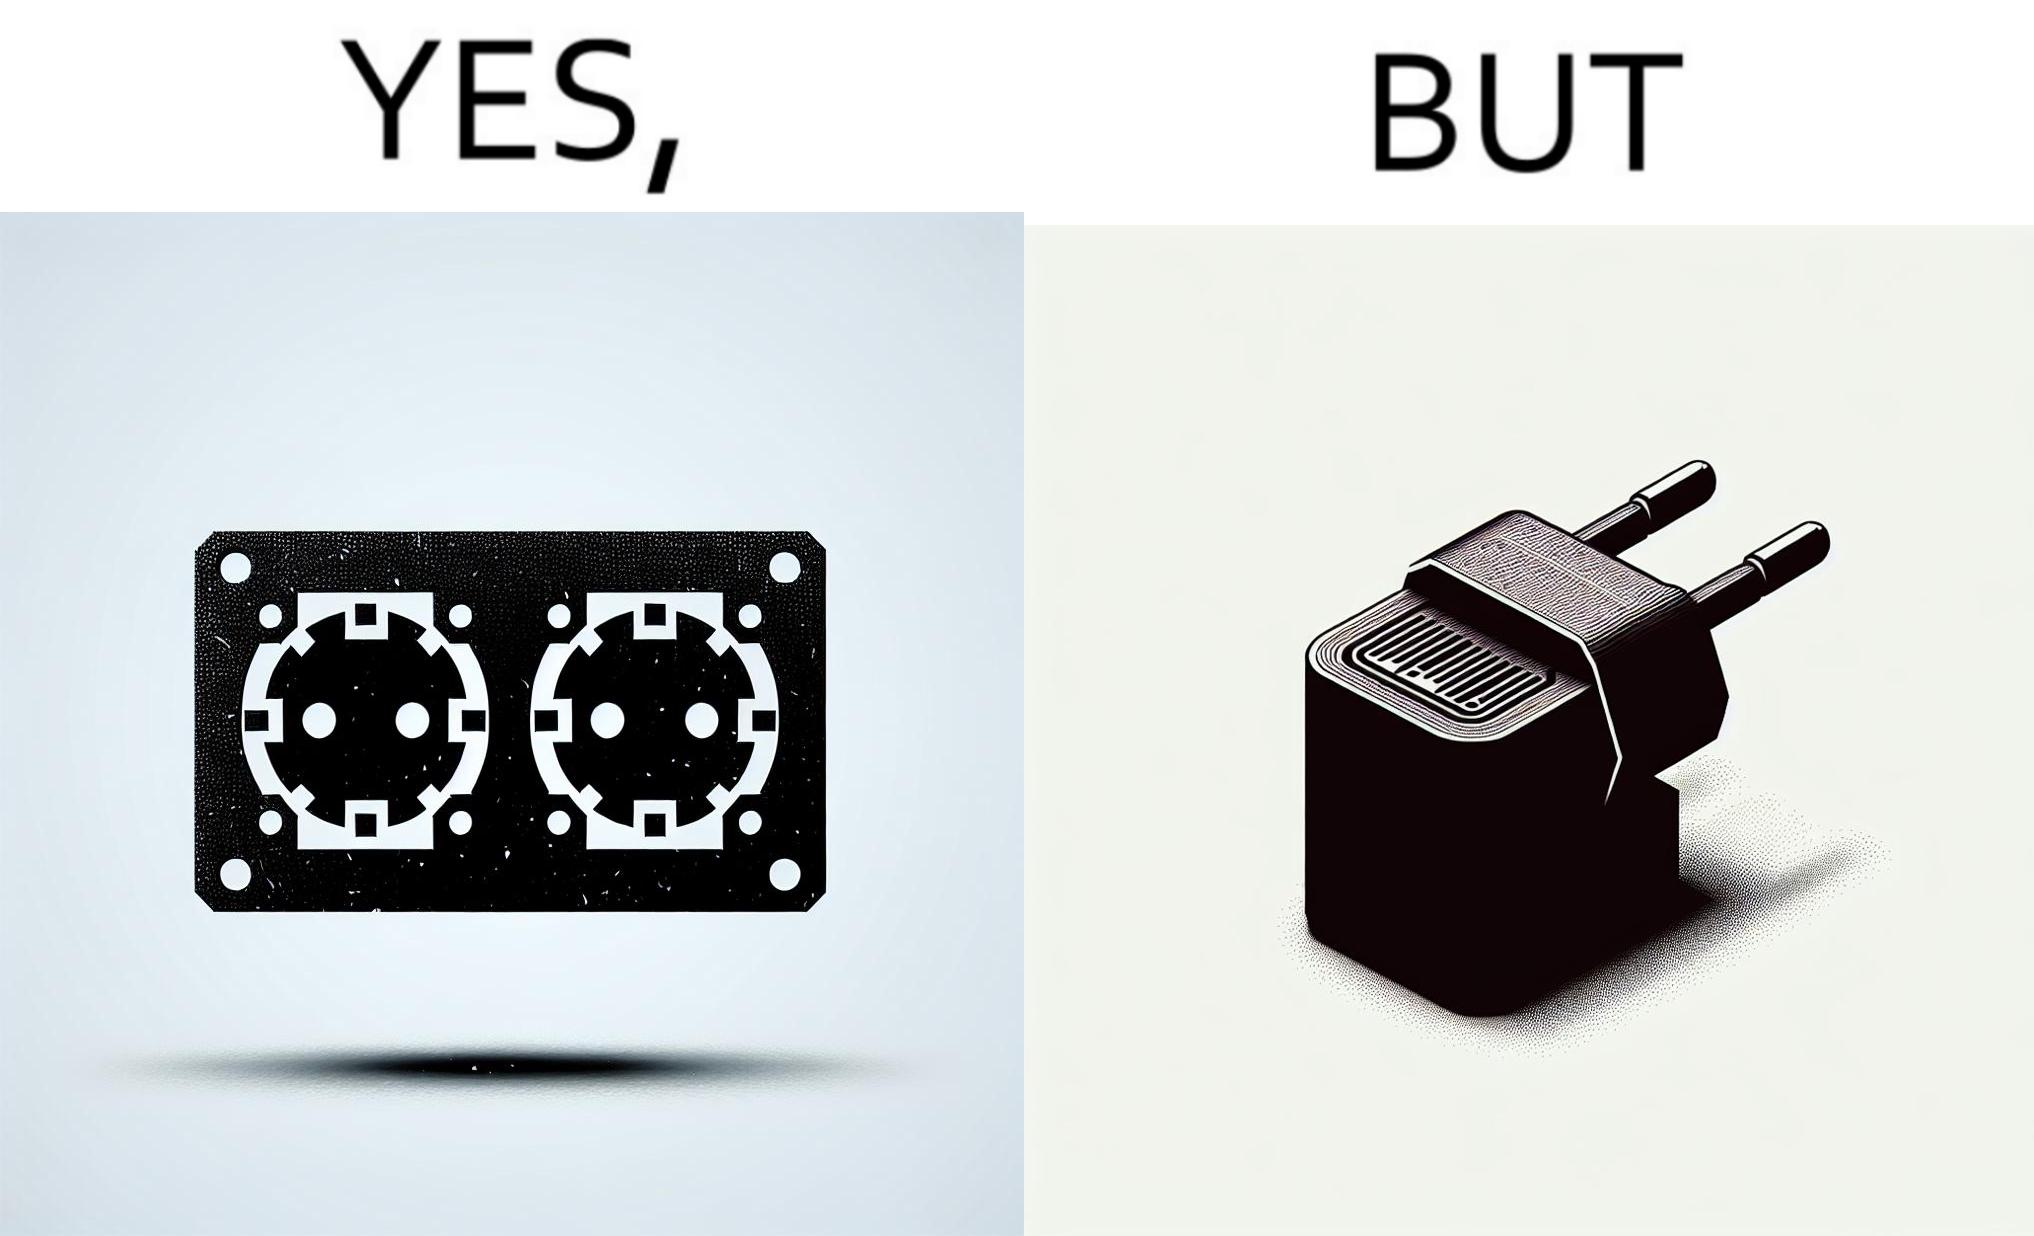Why is this image considered satirical? The image is funny, as there are two electrical sockets side-by-side, but the adapter is shaped in such a way, that if two adapters are inserted into the two sockets, they will butt into each other, leading to inconvenience. 